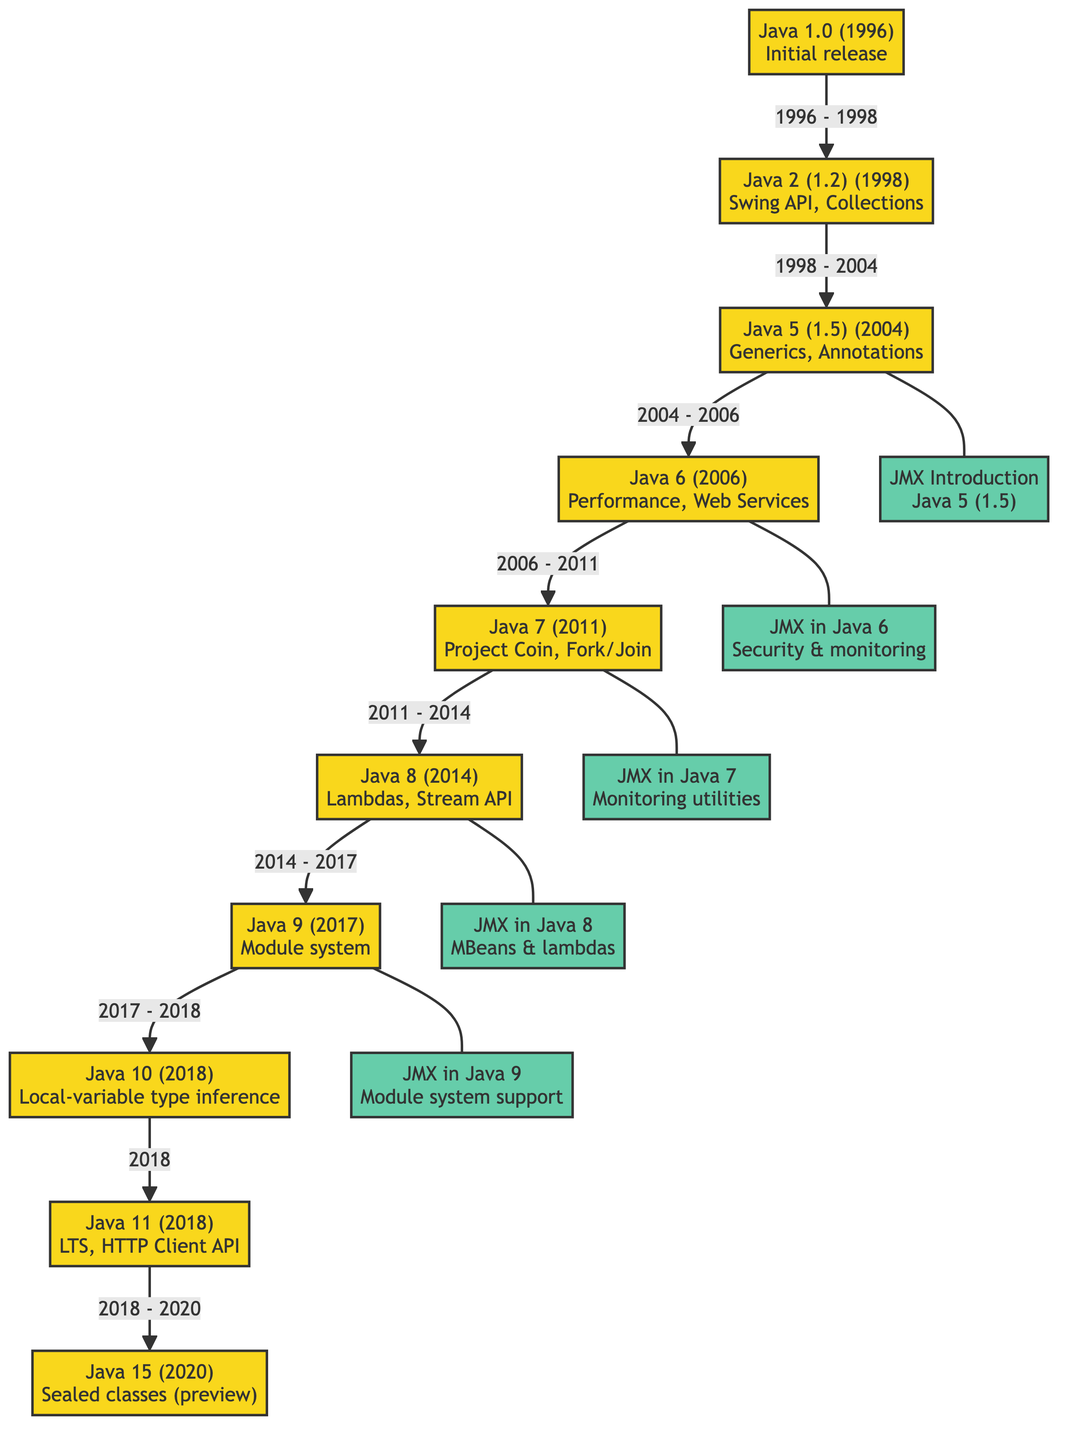What is the initial release year of Java? According to the diagram, Java 1.0 was released in 1996.
Answer: 1996 What major feature was introduced in Java 5? The diagram indicates that Java 5 introduced Generics and Annotations.
Answer: Generics, Annotations How many Java versions are represented in the diagram? By counting the nodes in the diagram, there are ten Java versions listed.
Answer: 10 Which Java version introduced the Module system? The diagram shows that the Module system was introduced in Java 9.
Answer: Java 9 What enhancement to JMX was made in Java 8? According to the diagram, Java 8 included enhancements related to MBeans and lambdas.
Answer: MBeans & lambdas Which Java version came immediately after Java 7? The diagram indicates that Java 8 followed Java 7 in the timeline flow.
Answer: Java 8 How are JMX updates connected to their corresponding Java versions? The diagram displays that JMX updates are associated with specific Java versions through direct connections (---).
Answer: Direct connections What was a major feature of Java 11? The diagram specifies that Java 11 included LTS (Long-Term Support) and the HTTP Client API.
Answer: LTS, HTTP Client API What JMX feature was introduced in Java 6? Java 6 improved JMX with security and monitoring features as shown in the diagram.
Answer: Security & monitoring Which Java version had the earliest enhancements to JMX? The diagram states that JMX was introduced in Java 5.
Answer: Java 5 